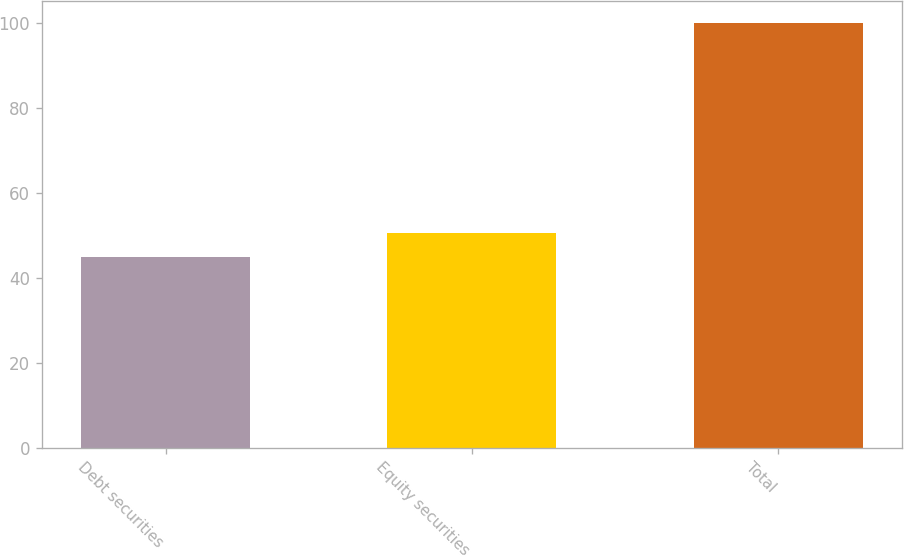Convert chart. <chart><loc_0><loc_0><loc_500><loc_500><bar_chart><fcel>Debt securities<fcel>Equity securities<fcel>Total<nl><fcel>45<fcel>50.5<fcel>100<nl></chart> 